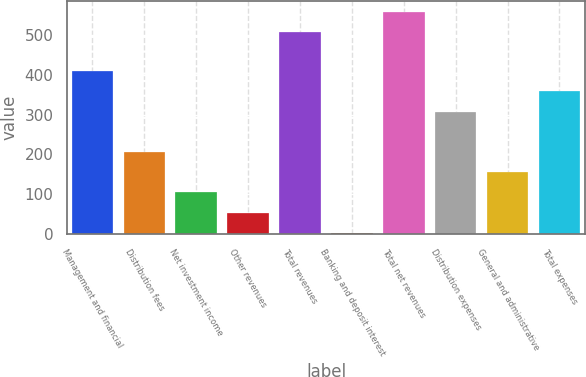Convert chart. <chart><loc_0><loc_0><loc_500><loc_500><bar_chart><fcel>Management and financial<fcel>Distribution fees<fcel>Net investment income<fcel>Other revenues<fcel>Total revenues<fcel>Banking and deposit interest<fcel>Total net revenues<fcel>Distribution expenses<fcel>General and administrative<fcel>Total expenses<nl><fcel>409.4<fcel>206.2<fcel>104.6<fcel>53.8<fcel>508<fcel>3<fcel>558.8<fcel>307.8<fcel>155.4<fcel>358.6<nl></chart> 